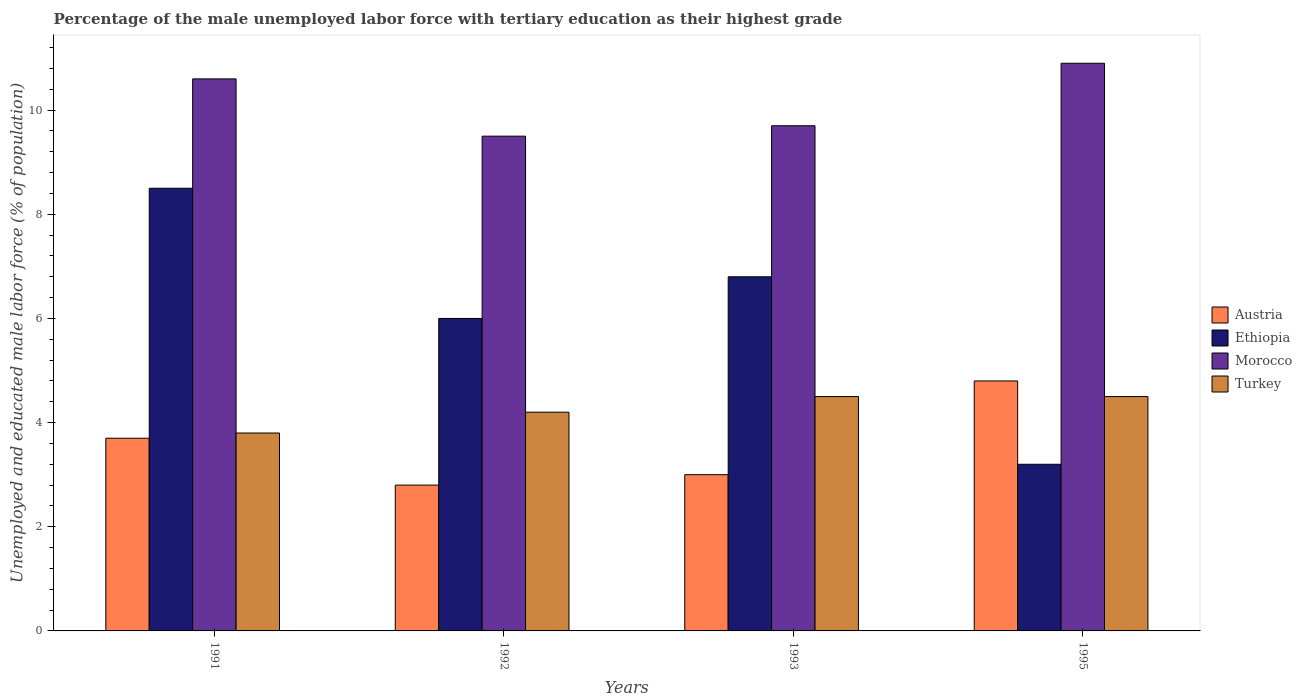How many bars are there on the 2nd tick from the left?
Ensure brevity in your answer.  4. In how many cases, is the number of bars for a given year not equal to the number of legend labels?
Offer a terse response. 0. What is the percentage of the unemployed male labor force with tertiary education in Turkey in 1995?
Your response must be concise. 4.5. Across all years, what is the maximum percentage of the unemployed male labor force with tertiary education in Austria?
Keep it short and to the point. 4.8. Across all years, what is the minimum percentage of the unemployed male labor force with tertiary education in Ethiopia?
Your answer should be compact. 3.2. What is the total percentage of the unemployed male labor force with tertiary education in Ethiopia in the graph?
Ensure brevity in your answer.  24.5. What is the difference between the percentage of the unemployed male labor force with tertiary education in Ethiopia in 1993 and that in 1995?
Offer a very short reply. 3.6. What is the difference between the percentage of the unemployed male labor force with tertiary education in Ethiopia in 1993 and the percentage of the unemployed male labor force with tertiary education in Austria in 1991?
Make the answer very short. 3.1. What is the average percentage of the unemployed male labor force with tertiary education in Turkey per year?
Give a very brief answer. 4.25. In the year 1992, what is the difference between the percentage of the unemployed male labor force with tertiary education in Austria and percentage of the unemployed male labor force with tertiary education in Ethiopia?
Your response must be concise. -3.2. In how many years, is the percentage of the unemployed male labor force with tertiary education in Turkey greater than 1.2000000000000002 %?
Your answer should be very brief. 4. What is the ratio of the percentage of the unemployed male labor force with tertiary education in Ethiopia in 1992 to that in 1995?
Keep it short and to the point. 1.87. Is the percentage of the unemployed male labor force with tertiary education in Morocco in 1991 less than that in 1993?
Offer a very short reply. No. What is the difference between the highest and the lowest percentage of the unemployed male labor force with tertiary education in Ethiopia?
Offer a very short reply. 5.3. In how many years, is the percentage of the unemployed male labor force with tertiary education in Austria greater than the average percentage of the unemployed male labor force with tertiary education in Austria taken over all years?
Offer a very short reply. 2. Is the sum of the percentage of the unemployed male labor force with tertiary education in Turkey in 1991 and 1992 greater than the maximum percentage of the unemployed male labor force with tertiary education in Morocco across all years?
Give a very brief answer. No. Is it the case that in every year, the sum of the percentage of the unemployed male labor force with tertiary education in Austria and percentage of the unemployed male labor force with tertiary education in Turkey is greater than the sum of percentage of the unemployed male labor force with tertiary education in Ethiopia and percentage of the unemployed male labor force with tertiary education in Morocco?
Give a very brief answer. No. What does the 3rd bar from the left in 1991 represents?
Keep it short and to the point. Morocco. What does the 3rd bar from the right in 1993 represents?
Make the answer very short. Ethiopia. Is it the case that in every year, the sum of the percentage of the unemployed male labor force with tertiary education in Turkey and percentage of the unemployed male labor force with tertiary education in Ethiopia is greater than the percentage of the unemployed male labor force with tertiary education in Morocco?
Provide a succinct answer. No. Are the values on the major ticks of Y-axis written in scientific E-notation?
Keep it short and to the point. No. Does the graph contain any zero values?
Provide a short and direct response. No. Where does the legend appear in the graph?
Offer a terse response. Center right. How are the legend labels stacked?
Your response must be concise. Vertical. What is the title of the graph?
Your answer should be very brief. Percentage of the male unemployed labor force with tertiary education as their highest grade. Does "Indonesia" appear as one of the legend labels in the graph?
Your answer should be compact. No. What is the label or title of the X-axis?
Your answer should be very brief. Years. What is the label or title of the Y-axis?
Your answer should be compact. Unemployed and educated male labor force (% of population). What is the Unemployed and educated male labor force (% of population) in Austria in 1991?
Provide a short and direct response. 3.7. What is the Unemployed and educated male labor force (% of population) in Morocco in 1991?
Your answer should be compact. 10.6. What is the Unemployed and educated male labor force (% of population) in Turkey in 1991?
Keep it short and to the point. 3.8. What is the Unemployed and educated male labor force (% of population) of Austria in 1992?
Offer a very short reply. 2.8. What is the Unemployed and educated male labor force (% of population) of Turkey in 1992?
Ensure brevity in your answer.  4.2. What is the Unemployed and educated male labor force (% of population) in Ethiopia in 1993?
Offer a very short reply. 6.8. What is the Unemployed and educated male labor force (% of population) in Morocco in 1993?
Give a very brief answer. 9.7. What is the Unemployed and educated male labor force (% of population) in Turkey in 1993?
Keep it short and to the point. 4.5. What is the Unemployed and educated male labor force (% of population) in Austria in 1995?
Provide a short and direct response. 4.8. What is the Unemployed and educated male labor force (% of population) in Ethiopia in 1995?
Offer a terse response. 3.2. What is the Unemployed and educated male labor force (% of population) of Morocco in 1995?
Your response must be concise. 10.9. Across all years, what is the maximum Unemployed and educated male labor force (% of population) of Austria?
Your response must be concise. 4.8. Across all years, what is the maximum Unemployed and educated male labor force (% of population) in Morocco?
Give a very brief answer. 10.9. Across all years, what is the minimum Unemployed and educated male labor force (% of population) in Austria?
Offer a very short reply. 2.8. Across all years, what is the minimum Unemployed and educated male labor force (% of population) of Ethiopia?
Offer a terse response. 3.2. Across all years, what is the minimum Unemployed and educated male labor force (% of population) in Morocco?
Your answer should be very brief. 9.5. Across all years, what is the minimum Unemployed and educated male labor force (% of population) of Turkey?
Give a very brief answer. 3.8. What is the total Unemployed and educated male labor force (% of population) in Morocco in the graph?
Your response must be concise. 40.7. What is the difference between the Unemployed and educated male labor force (% of population) in Austria in 1991 and that in 1992?
Provide a succinct answer. 0.9. What is the difference between the Unemployed and educated male labor force (% of population) of Austria in 1991 and that in 1993?
Your response must be concise. 0.7. What is the difference between the Unemployed and educated male labor force (% of population) of Ethiopia in 1991 and that in 1995?
Provide a succinct answer. 5.3. What is the difference between the Unemployed and educated male labor force (% of population) in Morocco in 1991 and that in 1995?
Make the answer very short. -0.3. What is the difference between the Unemployed and educated male labor force (% of population) in Ethiopia in 1992 and that in 1993?
Your response must be concise. -0.8. What is the difference between the Unemployed and educated male labor force (% of population) of Austria in 1992 and that in 1995?
Offer a terse response. -2. What is the difference between the Unemployed and educated male labor force (% of population) in Morocco in 1992 and that in 1995?
Offer a terse response. -1.4. What is the difference between the Unemployed and educated male labor force (% of population) in Austria in 1993 and that in 1995?
Make the answer very short. -1.8. What is the difference between the Unemployed and educated male labor force (% of population) in Ethiopia in 1993 and that in 1995?
Give a very brief answer. 3.6. What is the difference between the Unemployed and educated male labor force (% of population) in Austria in 1991 and the Unemployed and educated male labor force (% of population) in Ethiopia in 1992?
Offer a terse response. -2.3. What is the difference between the Unemployed and educated male labor force (% of population) in Austria in 1991 and the Unemployed and educated male labor force (% of population) in Morocco in 1992?
Give a very brief answer. -5.8. What is the difference between the Unemployed and educated male labor force (% of population) of Ethiopia in 1991 and the Unemployed and educated male labor force (% of population) of Morocco in 1992?
Offer a terse response. -1. What is the difference between the Unemployed and educated male labor force (% of population) in Ethiopia in 1991 and the Unemployed and educated male labor force (% of population) in Turkey in 1992?
Offer a very short reply. 4.3. What is the difference between the Unemployed and educated male labor force (% of population) of Austria in 1991 and the Unemployed and educated male labor force (% of population) of Ethiopia in 1993?
Your answer should be compact. -3.1. What is the difference between the Unemployed and educated male labor force (% of population) of Austria in 1991 and the Unemployed and educated male labor force (% of population) of Turkey in 1993?
Your answer should be compact. -0.8. What is the difference between the Unemployed and educated male labor force (% of population) of Ethiopia in 1991 and the Unemployed and educated male labor force (% of population) of Turkey in 1993?
Your response must be concise. 4. What is the difference between the Unemployed and educated male labor force (% of population) of Austria in 1991 and the Unemployed and educated male labor force (% of population) of Ethiopia in 1995?
Provide a short and direct response. 0.5. What is the difference between the Unemployed and educated male labor force (% of population) in Austria in 1991 and the Unemployed and educated male labor force (% of population) in Morocco in 1995?
Make the answer very short. -7.2. What is the difference between the Unemployed and educated male labor force (% of population) of Austria in 1991 and the Unemployed and educated male labor force (% of population) of Turkey in 1995?
Offer a terse response. -0.8. What is the difference between the Unemployed and educated male labor force (% of population) of Ethiopia in 1991 and the Unemployed and educated male labor force (% of population) of Morocco in 1995?
Offer a terse response. -2.4. What is the difference between the Unemployed and educated male labor force (% of population) in Ethiopia in 1991 and the Unemployed and educated male labor force (% of population) in Turkey in 1995?
Offer a very short reply. 4. What is the difference between the Unemployed and educated male labor force (% of population) in Morocco in 1991 and the Unemployed and educated male labor force (% of population) in Turkey in 1995?
Offer a very short reply. 6.1. What is the difference between the Unemployed and educated male labor force (% of population) in Austria in 1992 and the Unemployed and educated male labor force (% of population) in Morocco in 1993?
Keep it short and to the point. -6.9. What is the difference between the Unemployed and educated male labor force (% of population) in Austria in 1992 and the Unemployed and educated male labor force (% of population) in Turkey in 1993?
Ensure brevity in your answer.  -1.7. What is the difference between the Unemployed and educated male labor force (% of population) in Austria in 1992 and the Unemployed and educated male labor force (% of population) in Morocco in 1995?
Provide a succinct answer. -8.1. What is the difference between the Unemployed and educated male labor force (% of population) in Ethiopia in 1992 and the Unemployed and educated male labor force (% of population) in Morocco in 1995?
Give a very brief answer. -4.9. What is the difference between the Unemployed and educated male labor force (% of population) of Morocco in 1992 and the Unemployed and educated male labor force (% of population) of Turkey in 1995?
Offer a very short reply. 5. What is the difference between the Unemployed and educated male labor force (% of population) in Ethiopia in 1993 and the Unemployed and educated male labor force (% of population) in Morocco in 1995?
Ensure brevity in your answer.  -4.1. What is the difference between the Unemployed and educated male labor force (% of population) of Ethiopia in 1993 and the Unemployed and educated male labor force (% of population) of Turkey in 1995?
Your answer should be very brief. 2.3. What is the average Unemployed and educated male labor force (% of population) in Austria per year?
Your response must be concise. 3.58. What is the average Unemployed and educated male labor force (% of population) in Ethiopia per year?
Your answer should be very brief. 6.12. What is the average Unemployed and educated male labor force (% of population) of Morocco per year?
Provide a succinct answer. 10.18. What is the average Unemployed and educated male labor force (% of population) of Turkey per year?
Offer a very short reply. 4.25. In the year 1991, what is the difference between the Unemployed and educated male labor force (% of population) in Austria and Unemployed and educated male labor force (% of population) in Ethiopia?
Offer a very short reply. -4.8. In the year 1991, what is the difference between the Unemployed and educated male labor force (% of population) of Austria and Unemployed and educated male labor force (% of population) of Morocco?
Give a very brief answer. -6.9. In the year 1991, what is the difference between the Unemployed and educated male labor force (% of population) of Austria and Unemployed and educated male labor force (% of population) of Turkey?
Make the answer very short. -0.1. In the year 1992, what is the difference between the Unemployed and educated male labor force (% of population) in Ethiopia and Unemployed and educated male labor force (% of population) in Morocco?
Keep it short and to the point. -3.5. In the year 1992, what is the difference between the Unemployed and educated male labor force (% of population) in Ethiopia and Unemployed and educated male labor force (% of population) in Turkey?
Provide a short and direct response. 1.8. In the year 1993, what is the difference between the Unemployed and educated male labor force (% of population) of Austria and Unemployed and educated male labor force (% of population) of Morocco?
Keep it short and to the point. -6.7. In the year 1993, what is the difference between the Unemployed and educated male labor force (% of population) in Ethiopia and Unemployed and educated male labor force (% of population) in Morocco?
Keep it short and to the point. -2.9. In the year 1995, what is the difference between the Unemployed and educated male labor force (% of population) of Austria and Unemployed and educated male labor force (% of population) of Ethiopia?
Make the answer very short. 1.6. In the year 1995, what is the difference between the Unemployed and educated male labor force (% of population) of Austria and Unemployed and educated male labor force (% of population) of Morocco?
Ensure brevity in your answer.  -6.1. In the year 1995, what is the difference between the Unemployed and educated male labor force (% of population) in Austria and Unemployed and educated male labor force (% of population) in Turkey?
Offer a very short reply. 0.3. In the year 1995, what is the difference between the Unemployed and educated male labor force (% of population) in Ethiopia and Unemployed and educated male labor force (% of population) in Morocco?
Make the answer very short. -7.7. In the year 1995, what is the difference between the Unemployed and educated male labor force (% of population) of Morocco and Unemployed and educated male labor force (% of population) of Turkey?
Keep it short and to the point. 6.4. What is the ratio of the Unemployed and educated male labor force (% of population) of Austria in 1991 to that in 1992?
Your response must be concise. 1.32. What is the ratio of the Unemployed and educated male labor force (% of population) in Ethiopia in 1991 to that in 1992?
Your response must be concise. 1.42. What is the ratio of the Unemployed and educated male labor force (% of population) in Morocco in 1991 to that in 1992?
Offer a very short reply. 1.12. What is the ratio of the Unemployed and educated male labor force (% of population) in Turkey in 1991 to that in 1992?
Offer a very short reply. 0.9. What is the ratio of the Unemployed and educated male labor force (% of population) in Austria in 1991 to that in 1993?
Provide a succinct answer. 1.23. What is the ratio of the Unemployed and educated male labor force (% of population) of Ethiopia in 1991 to that in 1993?
Ensure brevity in your answer.  1.25. What is the ratio of the Unemployed and educated male labor force (% of population) of Morocco in 1991 to that in 1993?
Ensure brevity in your answer.  1.09. What is the ratio of the Unemployed and educated male labor force (% of population) in Turkey in 1991 to that in 1993?
Make the answer very short. 0.84. What is the ratio of the Unemployed and educated male labor force (% of population) of Austria in 1991 to that in 1995?
Provide a succinct answer. 0.77. What is the ratio of the Unemployed and educated male labor force (% of population) in Ethiopia in 1991 to that in 1995?
Your response must be concise. 2.66. What is the ratio of the Unemployed and educated male labor force (% of population) in Morocco in 1991 to that in 1995?
Offer a very short reply. 0.97. What is the ratio of the Unemployed and educated male labor force (% of population) of Turkey in 1991 to that in 1995?
Keep it short and to the point. 0.84. What is the ratio of the Unemployed and educated male labor force (% of population) in Ethiopia in 1992 to that in 1993?
Provide a succinct answer. 0.88. What is the ratio of the Unemployed and educated male labor force (% of population) in Morocco in 1992 to that in 1993?
Your response must be concise. 0.98. What is the ratio of the Unemployed and educated male labor force (% of population) in Austria in 1992 to that in 1995?
Your answer should be very brief. 0.58. What is the ratio of the Unemployed and educated male labor force (% of population) of Ethiopia in 1992 to that in 1995?
Keep it short and to the point. 1.88. What is the ratio of the Unemployed and educated male labor force (% of population) of Morocco in 1992 to that in 1995?
Make the answer very short. 0.87. What is the ratio of the Unemployed and educated male labor force (% of population) of Turkey in 1992 to that in 1995?
Your response must be concise. 0.93. What is the ratio of the Unemployed and educated male labor force (% of population) of Austria in 1993 to that in 1995?
Offer a very short reply. 0.62. What is the ratio of the Unemployed and educated male labor force (% of population) in Ethiopia in 1993 to that in 1995?
Offer a terse response. 2.12. What is the ratio of the Unemployed and educated male labor force (% of population) in Morocco in 1993 to that in 1995?
Provide a short and direct response. 0.89. What is the difference between the highest and the second highest Unemployed and educated male labor force (% of population) of Austria?
Offer a terse response. 1.1. What is the difference between the highest and the second highest Unemployed and educated male labor force (% of population) in Ethiopia?
Ensure brevity in your answer.  1.7. What is the difference between the highest and the second highest Unemployed and educated male labor force (% of population) in Turkey?
Make the answer very short. 0. What is the difference between the highest and the lowest Unemployed and educated male labor force (% of population) of Morocco?
Your answer should be compact. 1.4. What is the difference between the highest and the lowest Unemployed and educated male labor force (% of population) in Turkey?
Your response must be concise. 0.7. 